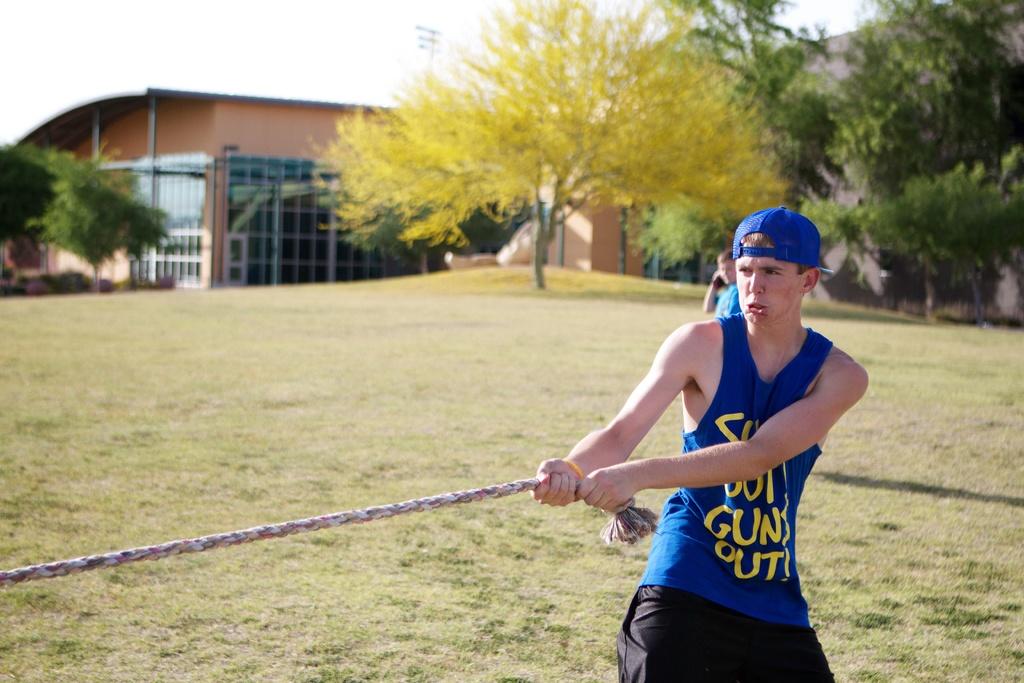What is out according to the shirt?
Keep it short and to the point. Guns. What is he pulling/?
Offer a very short reply. Answering does not require reading text in the image. 